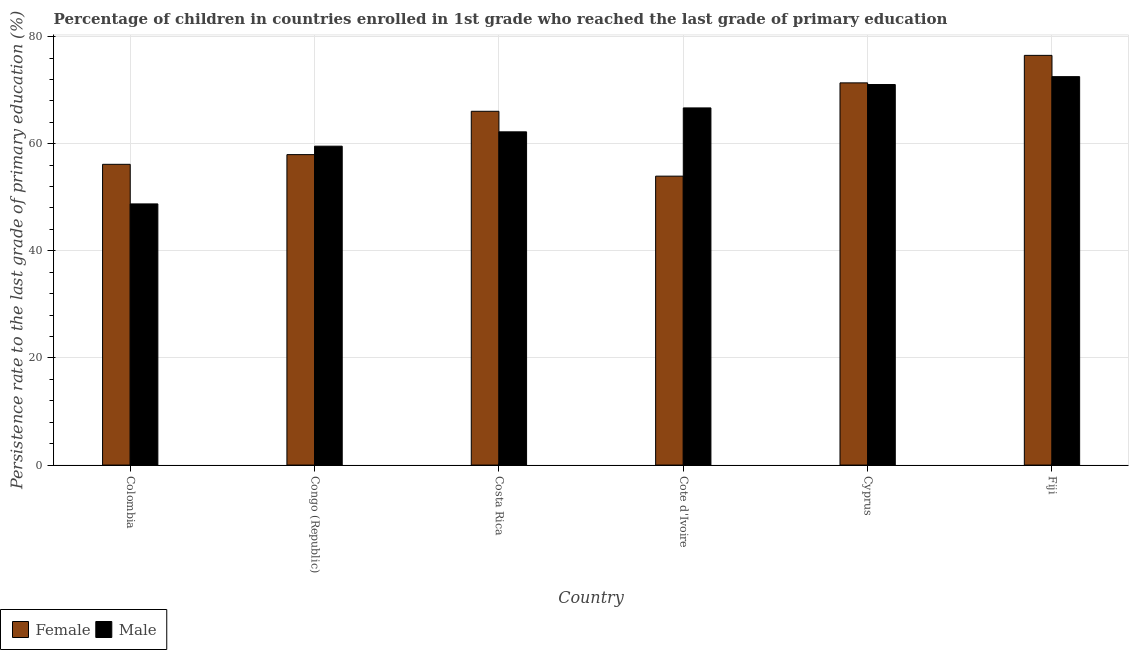How many different coloured bars are there?
Offer a terse response. 2. Are the number of bars on each tick of the X-axis equal?
Your answer should be very brief. Yes. How many bars are there on the 4th tick from the left?
Your answer should be very brief. 2. How many bars are there on the 6th tick from the right?
Ensure brevity in your answer.  2. What is the label of the 5th group of bars from the left?
Offer a terse response. Cyprus. In how many cases, is the number of bars for a given country not equal to the number of legend labels?
Make the answer very short. 0. What is the persistence rate of male students in Costa Rica?
Your answer should be compact. 62.22. Across all countries, what is the maximum persistence rate of male students?
Keep it short and to the point. 72.52. Across all countries, what is the minimum persistence rate of female students?
Provide a short and direct response. 53.94. In which country was the persistence rate of female students maximum?
Provide a succinct answer. Fiji. In which country was the persistence rate of female students minimum?
Provide a short and direct response. Cote d'Ivoire. What is the total persistence rate of female students in the graph?
Offer a terse response. 381.96. What is the difference between the persistence rate of male students in Colombia and that in Fiji?
Offer a terse response. -23.76. What is the difference between the persistence rate of male students in Congo (Republic) and the persistence rate of female students in Colombia?
Offer a terse response. 3.39. What is the average persistence rate of male students per country?
Your answer should be compact. 63.46. What is the difference between the persistence rate of female students and persistence rate of male students in Costa Rica?
Offer a terse response. 3.84. In how many countries, is the persistence rate of female students greater than 4 %?
Your response must be concise. 6. What is the ratio of the persistence rate of male students in Colombia to that in Cyprus?
Offer a very short reply. 0.69. Is the difference between the persistence rate of female students in Colombia and Costa Rica greater than the difference between the persistence rate of male students in Colombia and Costa Rica?
Your answer should be very brief. Yes. What is the difference between the highest and the second highest persistence rate of male students?
Offer a very short reply. 1.47. What is the difference between the highest and the lowest persistence rate of female students?
Make the answer very short. 22.55. In how many countries, is the persistence rate of male students greater than the average persistence rate of male students taken over all countries?
Ensure brevity in your answer.  3. What does the 2nd bar from the left in Cyprus represents?
Your response must be concise. Male. How many bars are there?
Give a very brief answer. 12. Are the values on the major ticks of Y-axis written in scientific E-notation?
Your answer should be compact. No. Does the graph contain grids?
Offer a very short reply. Yes. How are the legend labels stacked?
Provide a succinct answer. Horizontal. What is the title of the graph?
Give a very brief answer. Percentage of children in countries enrolled in 1st grade who reached the last grade of primary education. Does "From human activities" appear as one of the legend labels in the graph?
Offer a very short reply. No. What is the label or title of the Y-axis?
Your response must be concise. Persistence rate to the last grade of primary education (%). What is the Persistence rate to the last grade of primary education (%) of Female in Colombia?
Offer a very short reply. 56.15. What is the Persistence rate to the last grade of primary education (%) in Male in Colombia?
Your answer should be compact. 48.76. What is the Persistence rate to the last grade of primary education (%) of Female in Congo (Republic)?
Provide a succinct answer. 57.96. What is the Persistence rate to the last grade of primary education (%) in Male in Congo (Republic)?
Offer a terse response. 59.54. What is the Persistence rate to the last grade of primary education (%) in Female in Costa Rica?
Offer a very short reply. 66.05. What is the Persistence rate to the last grade of primary education (%) in Male in Costa Rica?
Offer a terse response. 62.22. What is the Persistence rate to the last grade of primary education (%) of Female in Cote d'Ivoire?
Offer a terse response. 53.94. What is the Persistence rate to the last grade of primary education (%) of Male in Cote d'Ivoire?
Provide a short and direct response. 66.68. What is the Persistence rate to the last grade of primary education (%) of Female in Cyprus?
Your answer should be compact. 71.36. What is the Persistence rate to the last grade of primary education (%) in Male in Cyprus?
Ensure brevity in your answer.  71.05. What is the Persistence rate to the last grade of primary education (%) in Female in Fiji?
Offer a terse response. 76.49. What is the Persistence rate to the last grade of primary education (%) in Male in Fiji?
Offer a terse response. 72.52. Across all countries, what is the maximum Persistence rate to the last grade of primary education (%) in Female?
Your answer should be very brief. 76.49. Across all countries, what is the maximum Persistence rate to the last grade of primary education (%) of Male?
Make the answer very short. 72.52. Across all countries, what is the minimum Persistence rate to the last grade of primary education (%) in Female?
Offer a very short reply. 53.94. Across all countries, what is the minimum Persistence rate to the last grade of primary education (%) in Male?
Offer a very short reply. 48.76. What is the total Persistence rate to the last grade of primary education (%) of Female in the graph?
Provide a succinct answer. 381.96. What is the total Persistence rate to the last grade of primary education (%) in Male in the graph?
Your answer should be compact. 380.77. What is the difference between the Persistence rate to the last grade of primary education (%) of Female in Colombia and that in Congo (Republic)?
Offer a very short reply. -1.81. What is the difference between the Persistence rate to the last grade of primary education (%) of Male in Colombia and that in Congo (Republic)?
Your answer should be compact. -10.78. What is the difference between the Persistence rate to the last grade of primary education (%) of Female in Colombia and that in Costa Rica?
Your answer should be compact. -9.9. What is the difference between the Persistence rate to the last grade of primary education (%) in Male in Colombia and that in Costa Rica?
Offer a very short reply. -13.46. What is the difference between the Persistence rate to the last grade of primary education (%) of Female in Colombia and that in Cote d'Ivoire?
Offer a very short reply. 2.21. What is the difference between the Persistence rate to the last grade of primary education (%) of Male in Colombia and that in Cote d'Ivoire?
Provide a short and direct response. -17.92. What is the difference between the Persistence rate to the last grade of primary education (%) of Female in Colombia and that in Cyprus?
Ensure brevity in your answer.  -15.21. What is the difference between the Persistence rate to the last grade of primary education (%) in Male in Colombia and that in Cyprus?
Provide a succinct answer. -22.29. What is the difference between the Persistence rate to the last grade of primary education (%) of Female in Colombia and that in Fiji?
Offer a very short reply. -20.34. What is the difference between the Persistence rate to the last grade of primary education (%) of Male in Colombia and that in Fiji?
Your response must be concise. -23.76. What is the difference between the Persistence rate to the last grade of primary education (%) in Female in Congo (Republic) and that in Costa Rica?
Ensure brevity in your answer.  -8.09. What is the difference between the Persistence rate to the last grade of primary education (%) of Male in Congo (Republic) and that in Costa Rica?
Ensure brevity in your answer.  -2.68. What is the difference between the Persistence rate to the last grade of primary education (%) in Female in Congo (Republic) and that in Cote d'Ivoire?
Your answer should be compact. 4.02. What is the difference between the Persistence rate to the last grade of primary education (%) in Male in Congo (Republic) and that in Cote d'Ivoire?
Provide a short and direct response. -7.14. What is the difference between the Persistence rate to the last grade of primary education (%) in Female in Congo (Republic) and that in Cyprus?
Provide a short and direct response. -13.4. What is the difference between the Persistence rate to the last grade of primary education (%) of Male in Congo (Republic) and that in Cyprus?
Ensure brevity in your answer.  -11.51. What is the difference between the Persistence rate to the last grade of primary education (%) in Female in Congo (Republic) and that in Fiji?
Provide a succinct answer. -18.53. What is the difference between the Persistence rate to the last grade of primary education (%) in Male in Congo (Republic) and that in Fiji?
Offer a very short reply. -12.98. What is the difference between the Persistence rate to the last grade of primary education (%) in Female in Costa Rica and that in Cote d'Ivoire?
Ensure brevity in your answer.  12.11. What is the difference between the Persistence rate to the last grade of primary education (%) of Male in Costa Rica and that in Cote d'Ivoire?
Provide a short and direct response. -4.47. What is the difference between the Persistence rate to the last grade of primary education (%) in Female in Costa Rica and that in Cyprus?
Your answer should be compact. -5.31. What is the difference between the Persistence rate to the last grade of primary education (%) of Male in Costa Rica and that in Cyprus?
Your answer should be compact. -8.84. What is the difference between the Persistence rate to the last grade of primary education (%) of Female in Costa Rica and that in Fiji?
Offer a very short reply. -10.44. What is the difference between the Persistence rate to the last grade of primary education (%) in Male in Costa Rica and that in Fiji?
Provide a succinct answer. -10.31. What is the difference between the Persistence rate to the last grade of primary education (%) of Female in Cote d'Ivoire and that in Cyprus?
Offer a very short reply. -17.42. What is the difference between the Persistence rate to the last grade of primary education (%) in Male in Cote d'Ivoire and that in Cyprus?
Your answer should be compact. -4.37. What is the difference between the Persistence rate to the last grade of primary education (%) of Female in Cote d'Ivoire and that in Fiji?
Keep it short and to the point. -22.55. What is the difference between the Persistence rate to the last grade of primary education (%) of Male in Cote d'Ivoire and that in Fiji?
Your response must be concise. -5.84. What is the difference between the Persistence rate to the last grade of primary education (%) in Female in Cyprus and that in Fiji?
Your answer should be compact. -5.14. What is the difference between the Persistence rate to the last grade of primary education (%) in Male in Cyprus and that in Fiji?
Offer a terse response. -1.47. What is the difference between the Persistence rate to the last grade of primary education (%) of Female in Colombia and the Persistence rate to the last grade of primary education (%) of Male in Congo (Republic)?
Provide a short and direct response. -3.39. What is the difference between the Persistence rate to the last grade of primary education (%) of Female in Colombia and the Persistence rate to the last grade of primary education (%) of Male in Costa Rica?
Your response must be concise. -6.06. What is the difference between the Persistence rate to the last grade of primary education (%) of Female in Colombia and the Persistence rate to the last grade of primary education (%) of Male in Cote d'Ivoire?
Keep it short and to the point. -10.53. What is the difference between the Persistence rate to the last grade of primary education (%) in Female in Colombia and the Persistence rate to the last grade of primary education (%) in Male in Cyprus?
Your answer should be compact. -14.9. What is the difference between the Persistence rate to the last grade of primary education (%) in Female in Colombia and the Persistence rate to the last grade of primary education (%) in Male in Fiji?
Your answer should be compact. -16.37. What is the difference between the Persistence rate to the last grade of primary education (%) in Female in Congo (Republic) and the Persistence rate to the last grade of primary education (%) in Male in Costa Rica?
Make the answer very short. -4.25. What is the difference between the Persistence rate to the last grade of primary education (%) of Female in Congo (Republic) and the Persistence rate to the last grade of primary education (%) of Male in Cote d'Ivoire?
Give a very brief answer. -8.72. What is the difference between the Persistence rate to the last grade of primary education (%) in Female in Congo (Republic) and the Persistence rate to the last grade of primary education (%) in Male in Cyprus?
Give a very brief answer. -13.09. What is the difference between the Persistence rate to the last grade of primary education (%) in Female in Congo (Republic) and the Persistence rate to the last grade of primary education (%) in Male in Fiji?
Your response must be concise. -14.56. What is the difference between the Persistence rate to the last grade of primary education (%) of Female in Costa Rica and the Persistence rate to the last grade of primary education (%) of Male in Cote d'Ivoire?
Provide a short and direct response. -0.63. What is the difference between the Persistence rate to the last grade of primary education (%) in Female in Costa Rica and the Persistence rate to the last grade of primary education (%) in Male in Cyprus?
Provide a succinct answer. -5. What is the difference between the Persistence rate to the last grade of primary education (%) in Female in Costa Rica and the Persistence rate to the last grade of primary education (%) in Male in Fiji?
Provide a short and direct response. -6.47. What is the difference between the Persistence rate to the last grade of primary education (%) of Female in Cote d'Ivoire and the Persistence rate to the last grade of primary education (%) of Male in Cyprus?
Your response must be concise. -17.11. What is the difference between the Persistence rate to the last grade of primary education (%) in Female in Cote d'Ivoire and the Persistence rate to the last grade of primary education (%) in Male in Fiji?
Make the answer very short. -18.58. What is the difference between the Persistence rate to the last grade of primary education (%) of Female in Cyprus and the Persistence rate to the last grade of primary education (%) of Male in Fiji?
Provide a succinct answer. -1.16. What is the average Persistence rate to the last grade of primary education (%) in Female per country?
Keep it short and to the point. 63.66. What is the average Persistence rate to the last grade of primary education (%) of Male per country?
Your answer should be compact. 63.46. What is the difference between the Persistence rate to the last grade of primary education (%) in Female and Persistence rate to the last grade of primary education (%) in Male in Colombia?
Provide a succinct answer. 7.39. What is the difference between the Persistence rate to the last grade of primary education (%) of Female and Persistence rate to the last grade of primary education (%) of Male in Congo (Republic)?
Make the answer very short. -1.57. What is the difference between the Persistence rate to the last grade of primary education (%) of Female and Persistence rate to the last grade of primary education (%) of Male in Costa Rica?
Your answer should be compact. 3.84. What is the difference between the Persistence rate to the last grade of primary education (%) in Female and Persistence rate to the last grade of primary education (%) in Male in Cote d'Ivoire?
Your answer should be compact. -12.74. What is the difference between the Persistence rate to the last grade of primary education (%) of Female and Persistence rate to the last grade of primary education (%) of Male in Cyprus?
Your answer should be compact. 0.31. What is the difference between the Persistence rate to the last grade of primary education (%) of Female and Persistence rate to the last grade of primary education (%) of Male in Fiji?
Provide a succinct answer. 3.97. What is the ratio of the Persistence rate to the last grade of primary education (%) of Female in Colombia to that in Congo (Republic)?
Give a very brief answer. 0.97. What is the ratio of the Persistence rate to the last grade of primary education (%) of Male in Colombia to that in Congo (Republic)?
Provide a short and direct response. 0.82. What is the ratio of the Persistence rate to the last grade of primary education (%) in Female in Colombia to that in Costa Rica?
Make the answer very short. 0.85. What is the ratio of the Persistence rate to the last grade of primary education (%) in Male in Colombia to that in Costa Rica?
Offer a terse response. 0.78. What is the ratio of the Persistence rate to the last grade of primary education (%) in Female in Colombia to that in Cote d'Ivoire?
Your answer should be very brief. 1.04. What is the ratio of the Persistence rate to the last grade of primary education (%) of Male in Colombia to that in Cote d'Ivoire?
Give a very brief answer. 0.73. What is the ratio of the Persistence rate to the last grade of primary education (%) in Female in Colombia to that in Cyprus?
Your answer should be very brief. 0.79. What is the ratio of the Persistence rate to the last grade of primary education (%) in Male in Colombia to that in Cyprus?
Provide a short and direct response. 0.69. What is the ratio of the Persistence rate to the last grade of primary education (%) of Female in Colombia to that in Fiji?
Your response must be concise. 0.73. What is the ratio of the Persistence rate to the last grade of primary education (%) in Male in Colombia to that in Fiji?
Ensure brevity in your answer.  0.67. What is the ratio of the Persistence rate to the last grade of primary education (%) in Female in Congo (Republic) to that in Costa Rica?
Keep it short and to the point. 0.88. What is the ratio of the Persistence rate to the last grade of primary education (%) in Female in Congo (Republic) to that in Cote d'Ivoire?
Ensure brevity in your answer.  1.07. What is the ratio of the Persistence rate to the last grade of primary education (%) of Male in Congo (Republic) to that in Cote d'Ivoire?
Provide a short and direct response. 0.89. What is the ratio of the Persistence rate to the last grade of primary education (%) of Female in Congo (Republic) to that in Cyprus?
Your response must be concise. 0.81. What is the ratio of the Persistence rate to the last grade of primary education (%) in Male in Congo (Republic) to that in Cyprus?
Keep it short and to the point. 0.84. What is the ratio of the Persistence rate to the last grade of primary education (%) in Female in Congo (Republic) to that in Fiji?
Offer a terse response. 0.76. What is the ratio of the Persistence rate to the last grade of primary education (%) of Male in Congo (Republic) to that in Fiji?
Your answer should be very brief. 0.82. What is the ratio of the Persistence rate to the last grade of primary education (%) in Female in Costa Rica to that in Cote d'Ivoire?
Your answer should be very brief. 1.22. What is the ratio of the Persistence rate to the last grade of primary education (%) of Male in Costa Rica to that in Cote d'Ivoire?
Offer a terse response. 0.93. What is the ratio of the Persistence rate to the last grade of primary education (%) of Female in Costa Rica to that in Cyprus?
Your response must be concise. 0.93. What is the ratio of the Persistence rate to the last grade of primary education (%) of Male in Costa Rica to that in Cyprus?
Offer a very short reply. 0.88. What is the ratio of the Persistence rate to the last grade of primary education (%) of Female in Costa Rica to that in Fiji?
Keep it short and to the point. 0.86. What is the ratio of the Persistence rate to the last grade of primary education (%) in Male in Costa Rica to that in Fiji?
Give a very brief answer. 0.86. What is the ratio of the Persistence rate to the last grade of primary education (%) in Female in Cote d'Ivoire to that in Cyprus?
Keep it short and to the point. 0.76. What is the ratio of the Persistence rate to the last grade of primary education (%) in Male in Cote d'Ivoire to that in Cyprus?
Your answer should be very brief. 0.94. What is the ratio of the Persistence rate to the last grade of primary education (%) of Female in Cote d'Ivoire to that in Fiji?
Your response must be concise. 0.71. What is the ratio of the Persistence rate to the last grade of primary education (%) of Male in Cote d'Ivoire to that in Fiji?
Keep it short and to the point. 0.92. What is the ratio of the Persistence rate to the last grade of primary education (%) in Female in Cyprus to that in Fiji?
Keep it short and to the point. 0.93. What is the ratio of the Persistence rate to the last grade of primary education (%) in Male in Cyprus to that in Fiji?
Offer a terse response. 0.98. What is the difference between the highest and the second highest Persistence rate to the last grade of primary education (%) of Female?
Provide a succinct answer. 5.14. What is the difference between the highest and the second highest Persistence rate to the last grade of primary education (%) in Male?
Keep it short and to the point. 1.47. What is the difference between the highest and the lowest Persistence rate to the last grade of primary education (%) of Female?
Ensure brevity in your answer.  22.55. What is the difference between the highest and the lowest Persistence rate to the last grade of primary education (%) of Male?
Give a very brief answer. 23.76. 